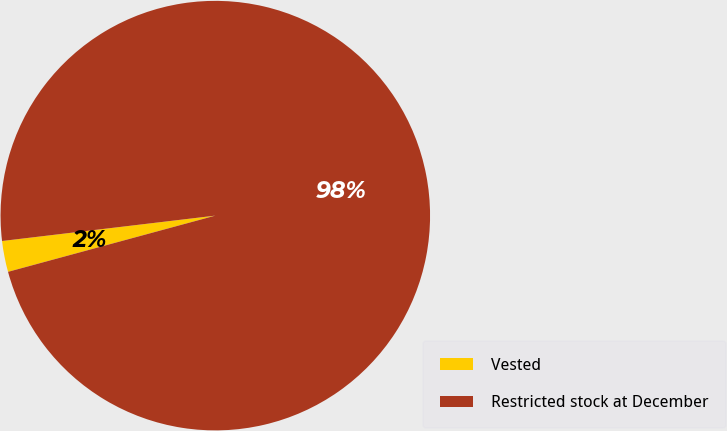Convert chart. <chart><loc_0><loc_0><loc_500><loc_500><pie_chart><fcel>Vested<fcel>Restricted stock at December<nl><fcel>2.33%<fcel>97.67%<nl></chart> 